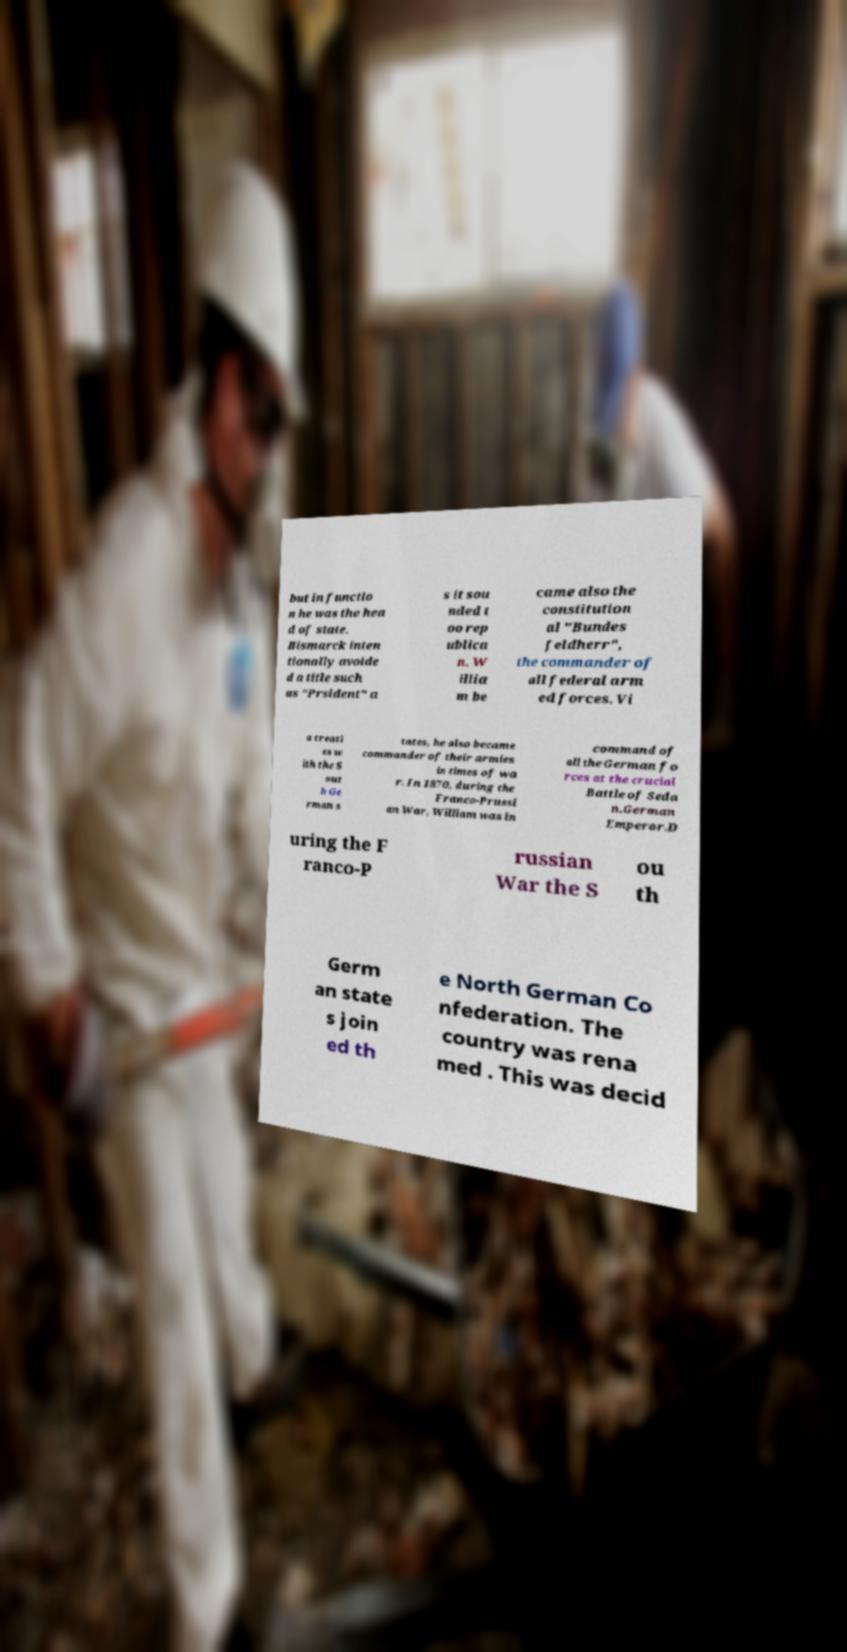Could you extract and type out the text from this image? but in functio n he was the hea d of state. Bismarck inten tionally avoide d a title such as "Prsident" a s it sou nded t oo rep ublica n. W illia m be came also the constitution al "Bundes feldherr", the commander of all federal arm ed forces. Vi a treati es w ith the S out h Ge rman s tates, he also became commander of their armies in times of wa r. In 1870, during the Franco-Prussi an War, William was in command of all the German fo rces at the crucial Battle of Seda n.German Emperor.D uring the F ranco-P russian War the S ou th Germ an state s join ed th e North German Co nfederation. The country was rena med . This was decid 